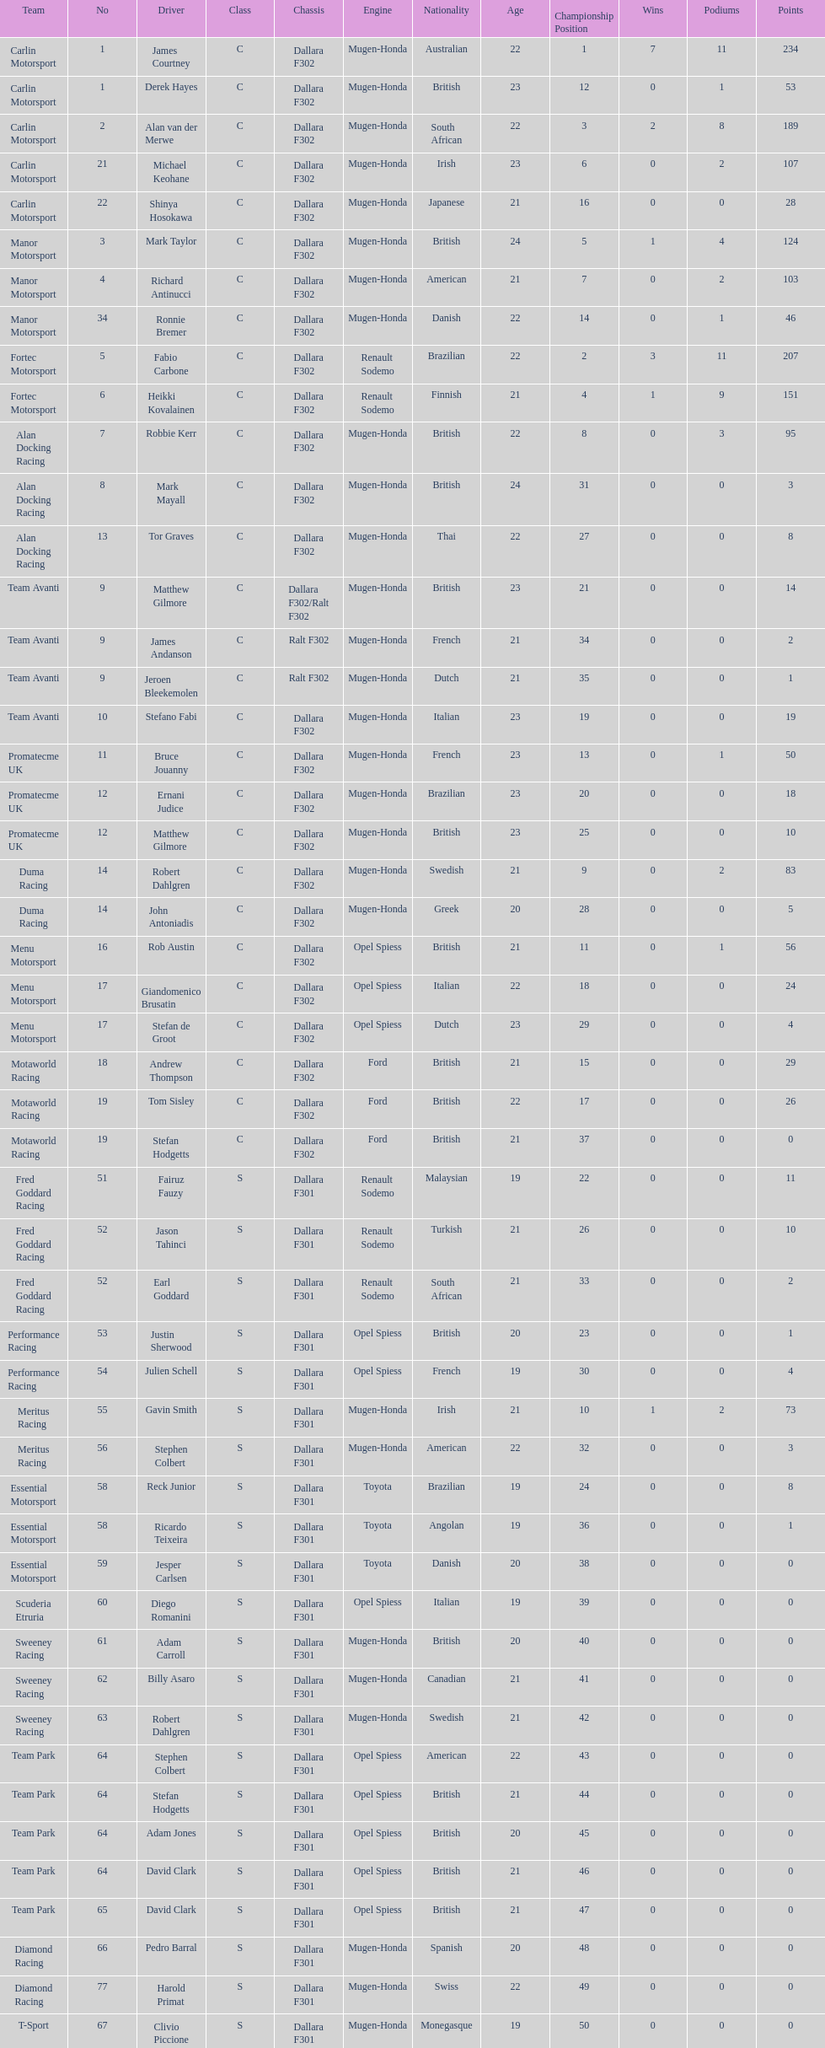How many teams had at least two drivers this season? 17. Write the full table. {'header': ['Team', 'No', 'Driver', 'Class', 'Chassis', 'Engine', 'Nationality', 'Age', 'Championship Position', 'Wins', 'Podiums', 'Points'], 'rows': [['Carlin Motorsport', '1', 'James Courtney', 'C', 'Dallara F302', 'Mugen-Honda', 'Australian', '22', '1', '7', '11', '234'], ['Carlin Motorsport', '1', 'Derek Hayes', 'C', 'Dallara F302', 'Mugen-Honda', 'British', '23', '12', '0', '1', '53'], ['Carlin Motorsport', '2', 'Alan van der Merwe', 'C', 'Dallara F302', 'Mugen-Honda', 'South African', '22', '3', '2', '8', '189'], ['Carlin Motorsport', '21', 'Michael Keohane', 'C', 'Dallara F302', 'Mugen-Honda', 'Irish', '23', '6', '0', '2', '107'], ['Carlin Motorsport', '22', 'Shinya Hosokawa', 'C', 'Dallara F302', 'Mugen-Honda', 'Japanese', '21', '16', '0', '0', '28'], ['Manor Motorsport', '3', 'Mark Taylor', 'C', 'Dallara F302', 'Mugen-Honda', 'British', '24', '5', '1', '4', '124'], ['Manor Motorsport', '4', 'Richard Antinucci', 'C', 'Dallara F302', 'Mugen-Honda', 'American', '21', '7', '0', '2', '103'], ['Manor Motorsport', '34', 'Ronnie Bremer', 'C', 'Dallara F302', 'Mugen-Honda', 'Danish', '22', '14', '0', '1', '46'], ['Fortec Motorsport', '5', 'Fabio Carbone', 'C', 'Dallara F302', 'Renault Sodemo', 'Brazilian', '22', '2', '3', '11', '207'], ['Fortec Motorsport', '6', 'Heikki Kovalainen', 'C', 'Dallara F302', 'Renault Sodemo', 'Finnish', '21', '4', '1', '9', '151'], ['Alan Docking Racing', '7', 'Robbie Kerr', 'C', 'Dallara F302', 'Mugen-Honda', 'British', '22', '8', '0', '3', '95'], ['Alan Docking Racing', '8', 'Mark Mayall', 'C', 'Dallara F302', 'Mugen-Honda', 'British', '24', '31', '0', '0', '3'], ['Alan Docking Racing', '13', 'Tor Graves', 'C', 'Dallara F302', 'Mugen-Honda', 'Thai', '22', '27', '0', '0', '8'], ['Team Avanti', '9', 'Matthew Gilmore', 'C', 'Dallara F302/Ralt F302', 'Mugen-Honda', 'British', '23', '21', '0', '0', '14'], ['Team Avanti', '9', 'James Andanson', 'C', 'Ralt F302', 'Mugen-Honda', 'French', '21', '34', '0', '0', '2'], ['Team Avanti', '9', 'Jeroen Bleekemolen', 'C', 'Ralt F302', 'Mugen-Honda', 'Dutch', '21', '35', '0', '0', '1'], ['Team Avanti', '10', 'Stefano Fabi', 'C', 'Dallara F302', 'Mugen-Honda', 'Italian', '23', '19', '0', '0', '19'], ['Promatecme UK', '11', 'Bruce Jouanny', 'C', 'Dallara F302', 'Mugen-Honda', 'French', '23', '13', '0', '1', '50'], ['Promatecme UK', '12', 'Ernani Judice', 'C', 'Dallara F302', 'Mugen-Honda', 'Brazilian', '23', '20', '0', '0', '18'], ['Promatecme UK', '12', 'Matthew Gilmore', 'C', 'Dallara F302', 'Mugen-Honda', 'British', '23', '25', '0', '0', '10'], ['Duma Racing', '14', 'Robert Dahlgren', 'C', 'Dallara F302', 'Mugen-Honda', 'Swedish', '21', '9', '0', '2', '83'], ['Duma Racing', '14', 'John Antoniadis', 'C', 'Dallara F302', 'Mugen-Honda', 'Greek', '20', '28', '0', '0', '5'], ['Menu Motorsport', '16', 'Rob Austin', 'C', 'Dallara F302', 'Opel Spiess', 'British', '21', '11', '0', '1', '56'], ['Menu Motorsport', '17', 'Giandomenico Brusatin', 'C', 'Dallara F302', 'Opel Spiess', 'Italian', '22', '18', '0', '0', '24'], ['Menu Motorsport', '17', 'Stefan de Groot', 'C', 'Dallara F302', 'Opel Spiess', 'Dutch', '23', '29', '0', '0', '4'], ['Motaworld Racing', '18', 'Andrew Thompson', 'C', 'Dallara F302', 'Ford', 'British', '21', '15', '0', '0', '29'], ['Motaworld Racing', '19', 'Tom Sisley', 'C', 'Dallara F302', 'Ford', 'British', '22', '17', '0', '0', '26'], ['Motaworld Racing', '19', 'Stefan Hodgetts', 'C', 'Dallara F302', 'Ford', 'British', '21', '37', '0', '0', '0'], ['Fred Goddard Racing', '51', 'Fairuz Fauzy', 'S', 'Dallara F301', 'Renault Sodemo', 'Malaysian', '19', '22', '0', '0', '11'], ['Fred Goddard Racing', '52', 'Jason Tahinci', 'S', 'Dallara F301', 'Renault Sodemo', 'Turkish', '21', '26', '0', '0', '10'], ['Fred Goddard Racing', '52', 'Earl Goddard', 'S', 'Dallara F301', 'Renault Sodemo', 'South African', '21', '33', '0', '0', '2'], ['Performance Racing', '53', 'Justin Sherwood', 'S', 'Dallara F301', 'Opel Spiess', 'British', '20', '23', '0', '0', '1'], ['Performance Racing', '54', 'Julien Schell', 'S', 'Dallara F301', 'Opel Spiess', 'French', '19', '30', '0', '0', '4'], ['Meritus Racing', '55', 'Gavin Smith', 'S', 'Dallara F301', 'Mugen-Honda', 'Irish', '21', '10', '1', '2', '73'], ['Meritus Racing', '56', 'Stephen Colbert', 'S', 'Dallara F301', 'Mugen-Honda', 'American', '22', '32', '0', '0', '3'], ['Essential Motorsport', '58', 'Reck Junior', 'S', 'Dallara F301', 'Toyota', 'Brazilian', '19', '24', '0', '0', '8'], ['Essential Motorsport', '58', 'Ricardo Teixeira', 'S', 'Dallara F301', 'Toyota', 'Angolan', '19', '36', '0', '0', '1'], ['Essential Motorsport', '59', 'Jesper Carlsen', 'S', 'Dallara F301', 'Toyota', 'Danish', '20', '38', '0', '0', '0'], ['Scuderia Etruria', '60', 'Diego Romanini', 'S', 'Dallara F301', 'Opel Spiess', 'Italian', '19', '39', '0', '0', '0'], ['Sweeney Racing', '61', 'Adam Carroll', 'S', 'Dallara F301', 'Mugen-Honda', 'British', '20', '40', '0', '0', '0'], ['Sweeney Racing', '62', 'Billy Asaro', 'S', 'Dallara F301', 'Mugen-Honda', 'Canadian', '21', '41', '0', '0', '0'], ['Sweeney Racing', '63', 'Robert Dahlgren', 'S', 'Dallara F301', 'Mugen-Honda', 'Swedish', '21', '42', '0', '0', '0'], ['Team Park', '64', 'Stephen Colbert', 'S', 'Dallara F301', 'Opel Spiess', 'American', '22', '43', '0', '0', '0'], ['Team Park', '64', 'Stefan Hodgetts', 'S', 'Dallara F301', 'Opel Spiess', 'British', '21', '44', '0', '0', '0'], ['Team Park', '64', 'Adam Jones', 'S', 'Dallara F301', 'Opel Spiess', 'British', '20', '45', '0', '0', '0'], ['Team Park', '64', 'David Clark', 'S', 'Dallara F301', 'Opel Spiess', 'British', '21', '46', '0', '0', '0'], ['Team Park', '65', 'David Clark', 'S', 'Dallara F301', 'Opel Spiess', 'British', '21', '47', '0', '0', '0'], ['Diamond Racing', '66', 'Pedro Barral', 'S', 'Dallara F301', 'Mugen-Honda', 'Spanish', '20', '48', '0', '0', '0'], ['Diamond Racing', '77', 'Harold Primat', 'S', 'Dallara F301', 'Mugen-Honda', 'Swiss', '22', '49', '0', '0', '0'], ['T-Sport', '67', 'Clivio Piccione', 'S', 'Dallara F301', 'Mugen-Honda', 'Monegasque', '19', '50', '0', '0', '0'], ['T-Sport', '68', 'Karun Chandhok', 'S', 'Dallara F301', 'Mugen-Honda', 'Indian', '18', '51', '0', '0', '0'], ['Hill Speed Motorsport', '69', 'Luke Stevens', 'S', 'Dallara F301', 'Opel Spiess', 'British', '21', '52', '0', '0', '0']]} 